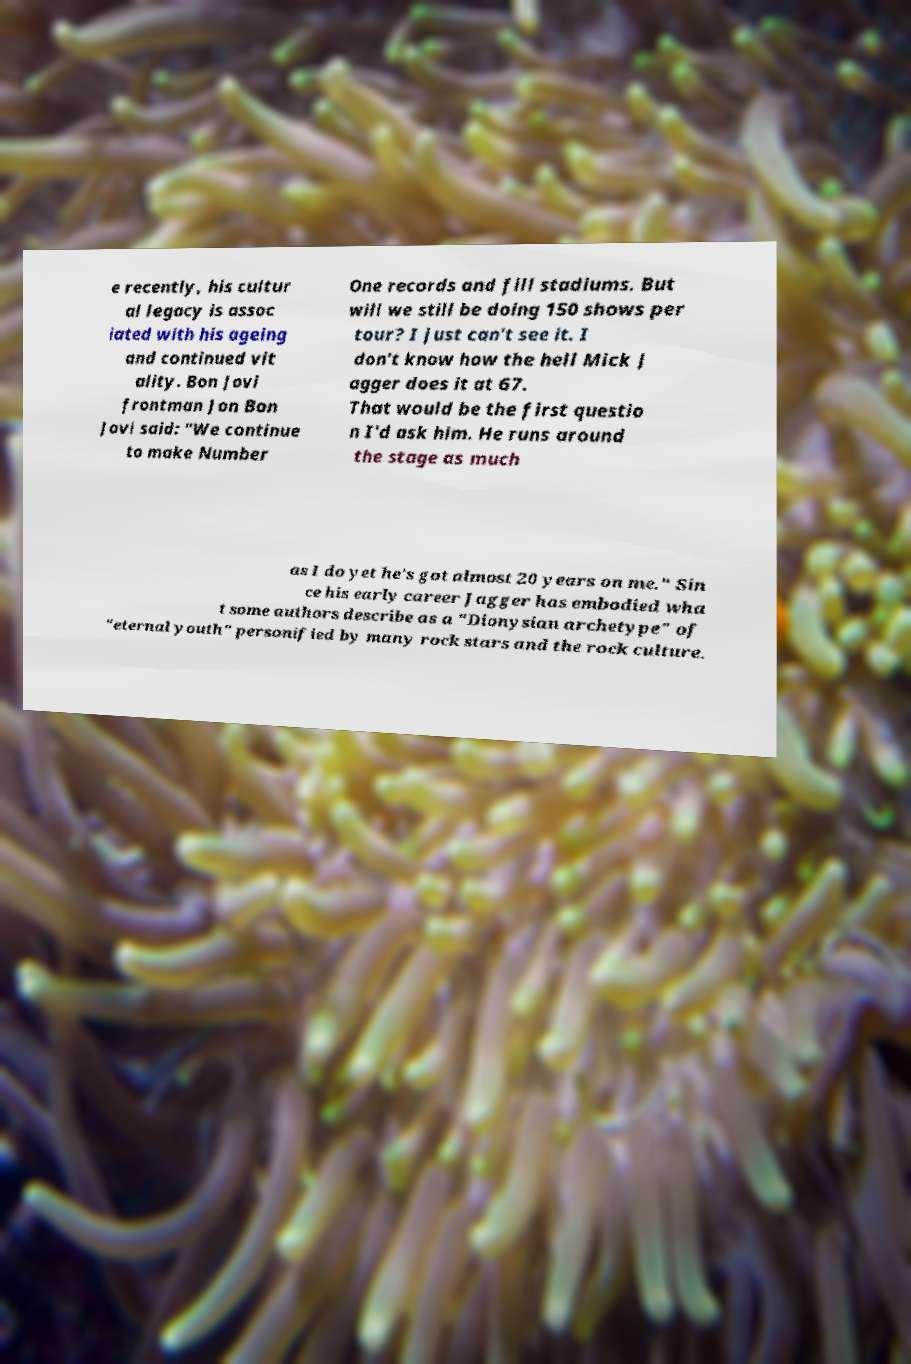There's text embedded in this image that I need extracted. Can you transcribe it verbatim? e recently, his cultur al legacy is assoc iated with his ageing and continued vit ality. Bon Jovi frontman Jon Bon Jovi said: "We continue to make Number One records and fill stadiums. But will we still be doing 150 shows per tour? I just can't see it. I don't know how the hell Mick J agger does it at 67. That would be the first questio n I'd ask him. He runs around the stage as much as I do yet he's got almost 20 years on me." Sin ce his early career Jagger has embodied wha t some authors describe as a "Dionysian archetype" of "eternal youth" personified by many rock stars and the rock culture. 